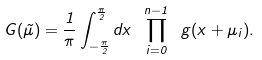<formula> <loc_0><loc_0><loc_500><loc_500>G ( \vec { \mu } ) = \frac { 1 } { \pi } \int _ { - \frac { \pi } { 2 } } ^ { \frac { \pi } { 2 } } d x \ \prod _ { i = 0 } ^ { n - 1 } \ g ( x + \mu _ { i } ) .</formula> 